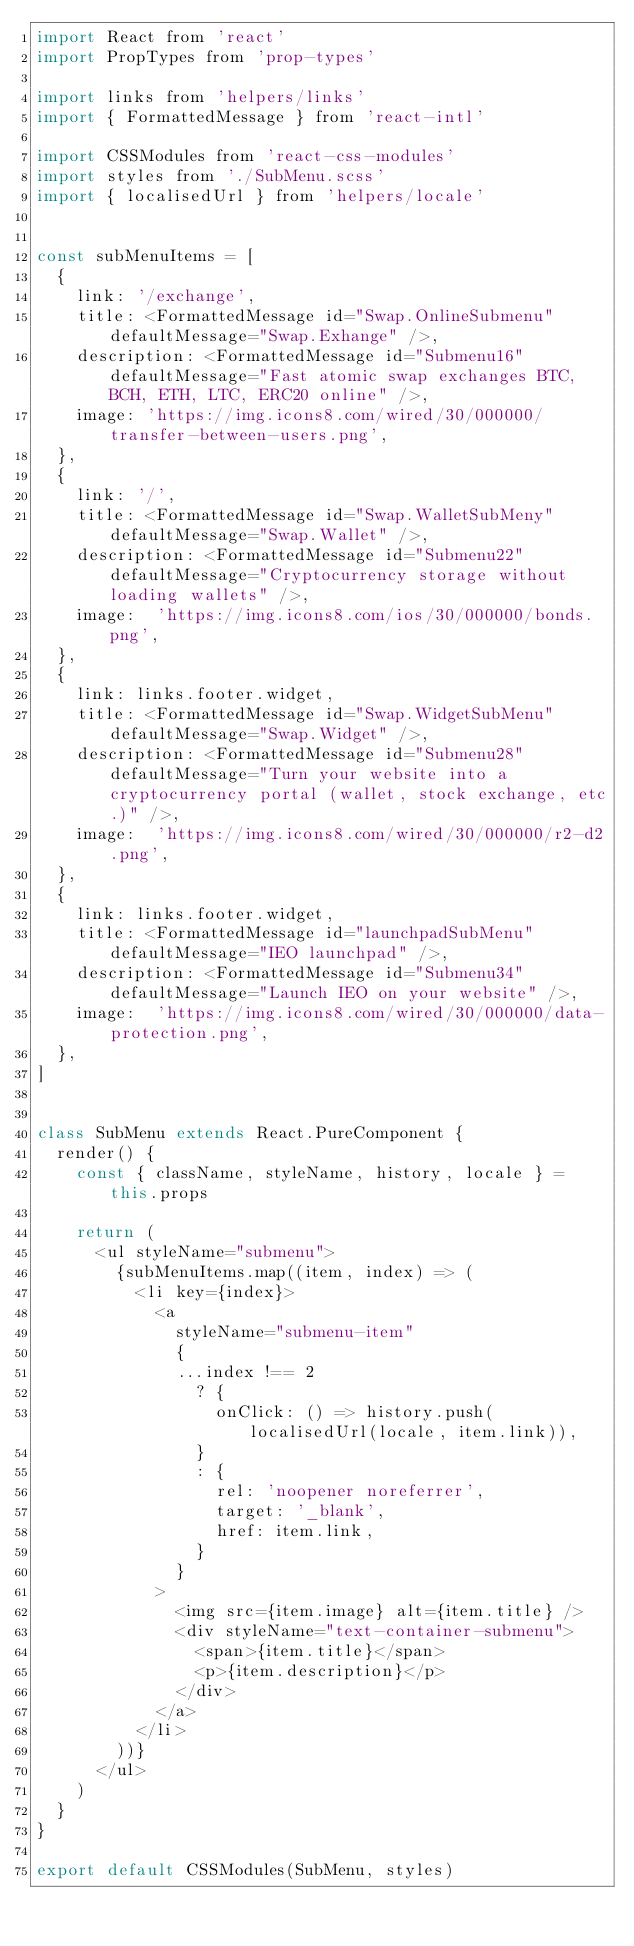Convert code to text. <code><loc_0><loc_0><loc_500><loc_500><_JavaScript_>import React from 'react'
import PropTypes from 'prop-types'

import links from 'helpers/links'
import { FormattedMessage } from 'react-intl'

import CSSModules from 'react-css-modules'
import styles from './SubMenu.scss'
import { localisedUrl } from 'helpers/locale'


const subMenuItems = [
  {
    link: '/exchange',
    title: <FormattedMessage id="Swap.OnlineSubmenu" defaultMessage="Swap.Exhange" />,
    description: <FormattedMessage id="Submenu16" defaultMessage="Fast atomic swap exchanges BTC, BCH, ETH, LTC, ERC20 online" />,
    image: 'https://img.icons8.com/wired/30/000000/transfer-between-users.png',
  },
  {
    link: '/',
    title: <FormattedMessage id="Swap.WalletSubMeny" defaultMessage="Swap.Wallet" />,
    description: <FormattedMessage id="Submenu22" defaultMessage="Cryptocurrency storage without loading wallets" />,
    image:  'https://img.icons8.com/ios/30/000000/bonds.png',
  },
  {
    link: links.footer.widget,
    title: <FormattedMessage id="Swap.WidgetSubMenu" defaultMessage="Swap.Widget" />,
    description: <FormattedMessage id="Submenu28" defaultMessage="Turn your website into a cryptocurrency portal (wallet, stock exchange, etc.)" />,
    image:  'https://img.icons8.com/wired/30/000000/r2-d2.png',
  },
  {
    link: links.footer.widget,
    title: <FormattedMessage id="launchpadSubMenu" defaultMessage="IEO launchpad" />,
    description: <FormattedMessage id="Submenu34" defaultMessage="Launch IEO on your website" />,
    image:  'https://img.icons8.com/wired/30/000000/data-protection.png',
  },
]


class SubMenu extends React.PureComponent {
  render() {
    const { className, styleName, history, locale } = this.props

    return (
      <ul styleName="submenu">
        {subMenuItems.map((item, index) => (
          <li key={index}>
            <a
              styleName="submenu-item"
              {
              ...index !== 2
                ? {
                  onClick: () => history.push(localisedUrl(locale, item.link)),
                }
                : {
                  rel: 'noopener noreferrer',
                  target: '_blank',
                  href: item.link,
                }
              }
            >
              <img src={item.image} alt={item.title} />
              <div styleName="text-container-submenu">
                <span>{item.title}</span>
                <p>{item.description}</p>
              </div>
            </a>
          </li>
        ))}
      </ul>
    )
  }
}

export default CSSModules(SubMenu, styles)
</code> 